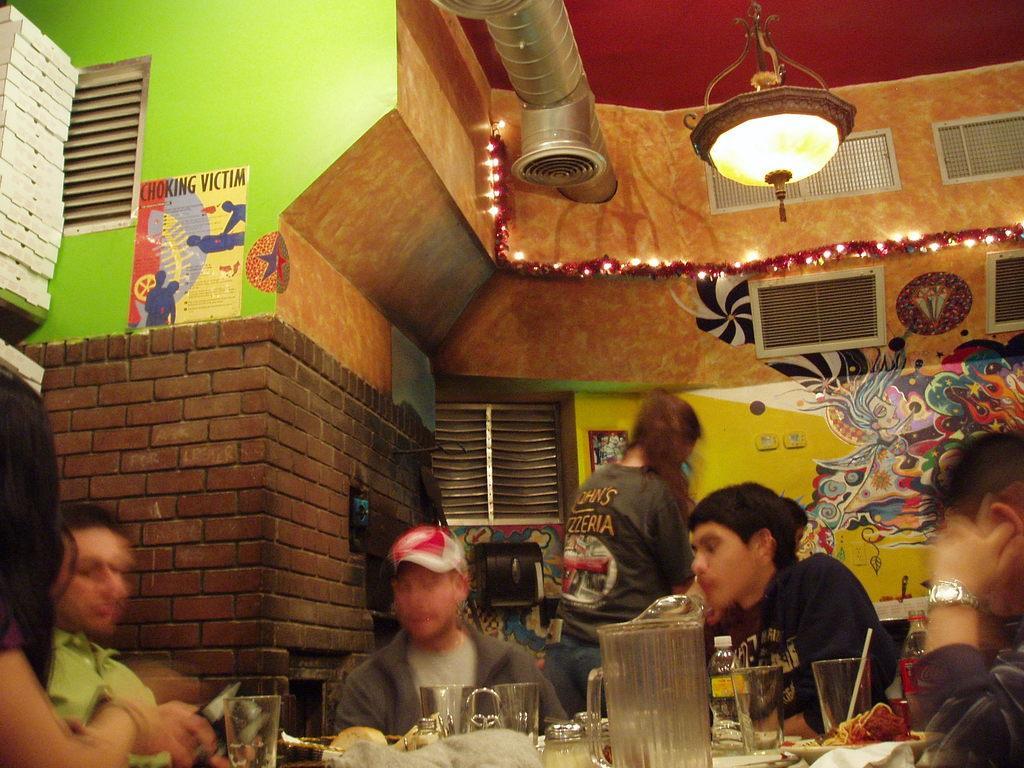Please provide a concise description of this image. This picture shows few people seated and a woman standing and we see painting on the wall and lights and we see man wore a cap on his head and we see glasses,bottle and jug and some food in the plates on the table and we see boxes on the shelf and a poster on the wall. 